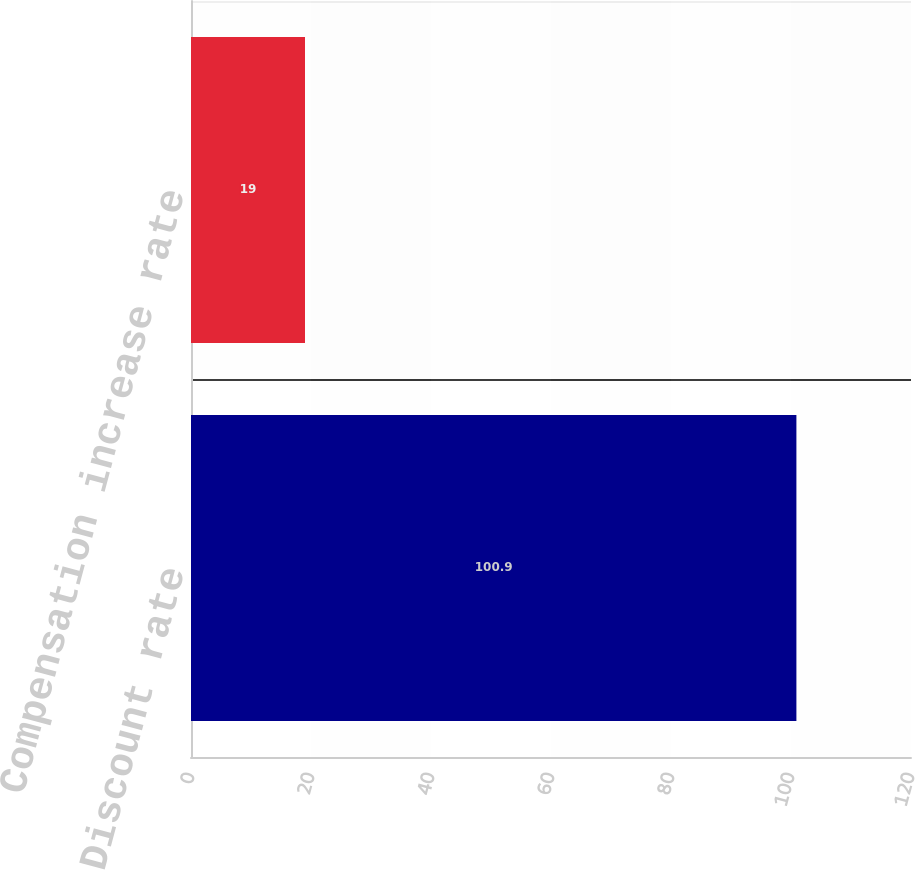Convert chart. <chart><loc_0><loc_0><loc_500><loc_500><bar_chart><fcel>Discount rate<fcel>Compensation increase rate<nl><fcel>100.9<fcel>19<nl></chart> 